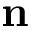Convert formula to latex. <formula><loc_0><loc_0><loc_500><loc_500>n</formula> 